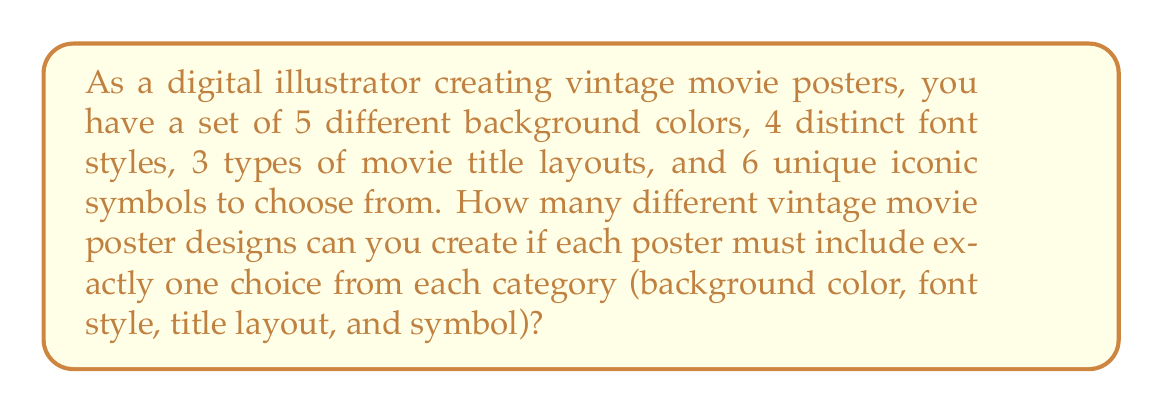Show me your answer to this math problem. Let's approach this step-by-step using the multiplication principle of counting:

1) For each poster, we need to make four independent choices:
   - Background color
   - Font style
   - Title layout
   - Iconic symbol

2) For each choice, we have:
   - 5 options for background color
   - 4 options for font style
   - 3 options for title layout
   - 6 options for iconic symbol

3) According to the multiplication principle, when we have a series of independent choices, we multiply the number of options for each choice to get the total number of possible outcomes.

4) Therefore, the total number of unique poster designs is:

   $$ 5 \times 4 \times 3 \times 6 $$

5) Let's calculate this:
   $$ 5 \times 4 \times 3 \times 6 = 360 $$

Thus, you can create 360 different vintage movie poster designs with the given set of elements.
Answer: 360 